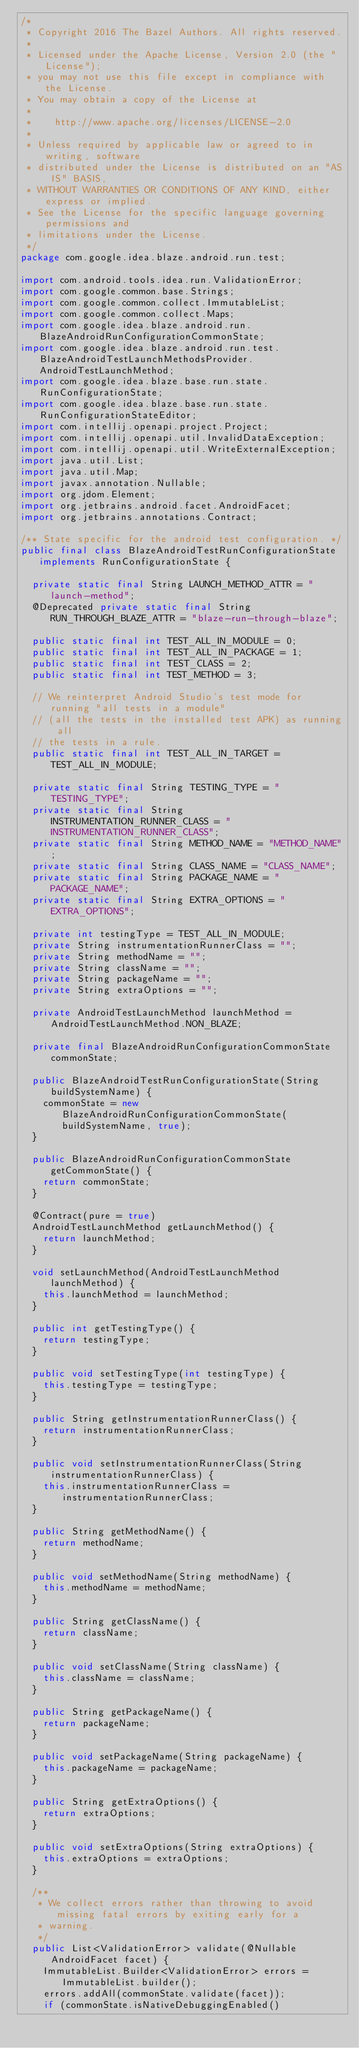Convert code to text. <code><loc_0><loc_0><loc_500><loc_500><_Java_>/*
 * Copyright 2016 The Bazel Authors. All rights reserved.
 *
 * Licensed under the Apache License, Version 2.0 (the "License");
 * you may not use this file except in compliance with the License.
 * You may obtain a copy of the License at
 *
 *    http://www.apache.org/licenses/LICENSE-2.0
 *
 * Unless required by applicable law or agreed to in writing, software
 * distributed under the License is distributed on an "AS IS" BASIS,
 * WITHOUT WARRANTIES OR CONDITIONS OF ANY KIND, either express or implied.
 * See the License for the specific language governing permissions and
 * limitations under the License.
 */
package com.google.idea.blaze.android.run.test;

import com.android.tools.idea.run.ValidationError;
import com.google.common.base.Strings;
import com.google.common.collect.ImmutableList;
import com.google.common.collect.Maps;
import com.google.idea.blaze.android.run.BlazeAndroidRunConfigurationCommonState;
import com.google.idea.blaze.android.run.test.BlazeAndroidTestLaunchMethodsProvider.AndroidTestLaunchMethod;
import com.google.idea.blaze.base.run.state.RunConfigurationState;
import com.google.idea.blaze.base.run.state.RunConfigurationStateEditor;
import com.intellij.openapi.project.Project;
import com.intellij.openapi.util.InvalidDataException;
import com.intellij.openapi.util.WriteExternalException;
import java.util.List;
import java.util.Map;
import javax.annotation.Nullable;
import org.jdom.Element;
import org.jetbrains.android.facet.AndroidFacet;
import org.jetbrains.annotations.Contract;

/** State specific for the android test configuration. */
public final class BlazeAndroidTestRunConfigurationState implements RunConfigurationState {

  private static final String LAUNCH_METHOD_ATTR = "launch-method";
  @Deprecated private static final String RUN_THROUGH_BLAZE_ATTR = "blaze-run-through-blaze";

  public static final int TEST_ALL_IN_MODULE = 0;
  public static final int TEST_ALL_IN_PACKAGE = 1;
  public static final int TEST_CLASS = 2;
  public static final int TEST_METHOD = 3;

  // We reinterpret Android Studio's test mode for running "all tests in a module"
  // (all the tests in the installed test APK) as running all
  // the tests in a rule.
  public static final int TEST_ALL_IN_TARGET = TEST_ALL_IN_MODULE;

  private static final String TESTING_TYPE = "TESTING_TYPE";
  private static final String INSTRUMENTATION_RUNNER_CLASS = "INSTRUMENTATION_RUNNER_CLASS";
  private static final String METHOD_NAME = "METHOD_NAME";
  private static final String CLASS_NAME = "CLASS_NAME";
  private static final String PACKAGE_NAME = "PACKAGE_NAME";
  private static final String EXTRA_OPTIONS = "EXTRA_OPTIONS";

  private int testingType = TEST_ALL_IN_MODULE;
  private String instrumentationRunnerClass = "";
  private String methodName = "";
  private String className = "";
  private String packageName = "";
  private String extraOptions = "";

  private AndroidTestLaunchMethod launchMethod = AndroidTestLaunchMethod.NON_BLAZE;

  private final BlazeAndroidRunConfigurationCommonState commonState;

  public BlazeAndroidTestRunConfigurationState(String buildSystemName) {
    commonState = new BlazeAndroidRunConfigurationCommonState(buildSystemName, true);
  }

  public BlazeAndroidRunConfigurationCommonState getCommonState() {
    return commonState;
  }

  @Contract(pure = true)
  AndroidTestLaunchMethod getLaunchMethod() {
    return launchMethod;
  }

  void setLaunchMethod(AndroidTestLaunchMethod launchMethod) {
    this.launchMethod = launchMethod;
  }

  public int getTestingType() {
    return testingType;
  }

  public void setTestingType(int testingType) {
    this.testingType = testingType;
  }

  public String getInstrumentationRunnerClass() {
    return instrumentationRunnerClass;
  }

  public void setInstrumentationRunnerClass(String instrumentationRunnerClass) {
    this.instrumentationRunnerClass = instrumentationRunnerClass;
  }

  public String getMethodName() {
    return methodName;
  }

  public void setMethodName(String methodName) {
    this.methodName = methodName;
  }

  public String getClassName() {
    return className;
  }

  public void setClassName(String className) {
    this.className = className;
  }

  public String getPackageName() {
    return packageName;
  }

  public void setPackageName(String packageName) {
    this.packageName = packageName;
  }

  public String getExtraOptions() {
    return extraOptions;
  }

  public void setExtraOptions(String extraOptions) {
    this.extraOptions = extraOptions;
  }

  /**
   * We collect errors rather than throwing to avoid missing fatal errors by exiting early for a
   * warning.
   */
  public List<ValidationError> validate(@Nullable AndroidFacet facet) {
    ImmutableList.Builder<ValidationError> errors = ImmutableList.builder();
    errors.addAll(commonState.validate(facet));
    if (commonState.isNativeDebuggingEnabled()</code> 